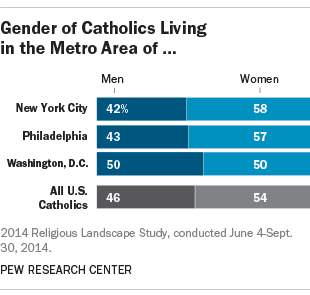Can we infer any trends about the Catholic population in these metropolitan areas from this chart? While the chart is strictly about gender distribution and doesn't provide extensive data on other aspects, one could infer that, in these metro areas, there is a trend of women being more prevalent within the Catholic community than men. This differs from the national average, albeit slightly in the case of New York City and Philadelphia. Washington, D.C., stands out with an equal split, which could be viewed as a unique characteristic of its Catholic demographic. 